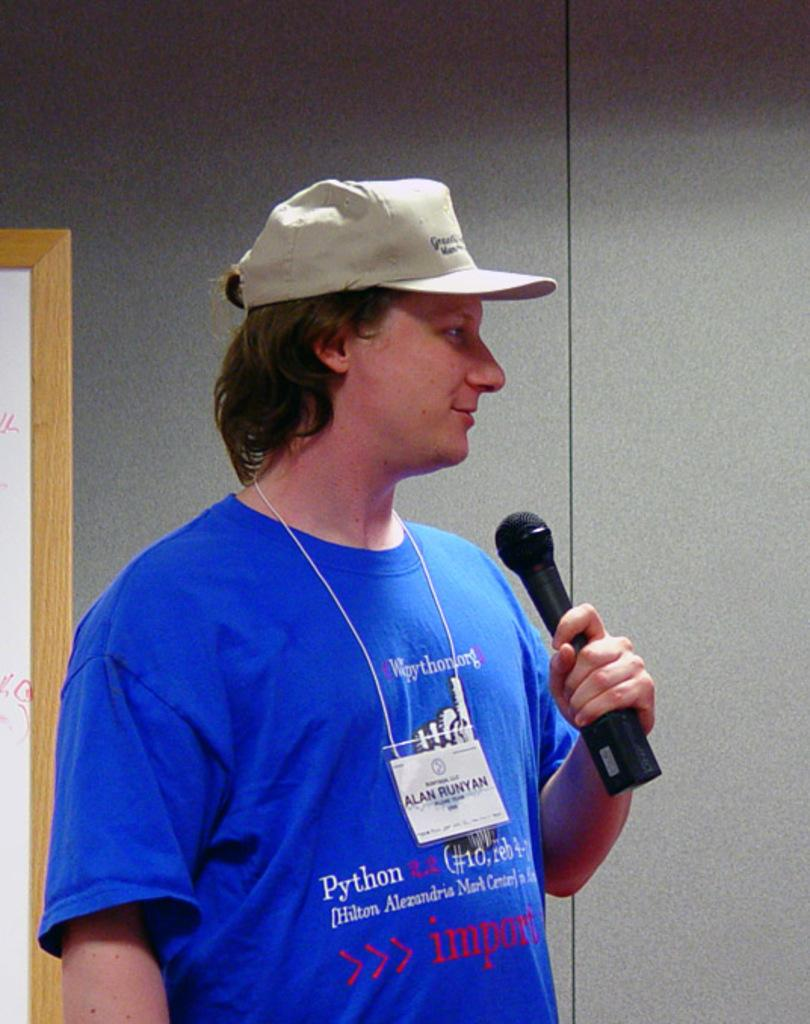What is the main subject of the image? There is a person in the image. What is the person holding in the image? The person is holding a microphone. What type of headwear is the person wearing? The person is wearing a cap. What can be seen in the background of the image? There is a wall in the background of the image. Reasoning: Let' Let's think step by step in order to produce the conversation. We start by identifying the main subject of the image, which is the person. Then, we describe what the person is holding, which is a microphone. Next, we mention the person's headwear, which is a cap. Finally, we describe the background of the image, which features a wall. Absurd Question/Answer: What type of needle is being used for learning in the image? There is no needle or learning activity present in the image. What is the main subject of the image? There is a car in the image. What color is the car? The car is red. How many wheels does the car have? The car has four wheels. What can be seen in the background of the image? There is a road in the image. What type of surface is the road made of? The road is paved. Reasoning: Let's think step by step in order to produce the conversation. We start by identifying the main subject of the image, which is the car. Then, we describe the car's color and the number of wheels it has. Next, we mention the background of the image, which features a road. Finally, we describe the road's surface, which is paved. Absurd Question/Answer: Can you see a parrot flying over the ocean in the image? There is no parrot or ocean present in the image; it features a red car with four wheels and a p 